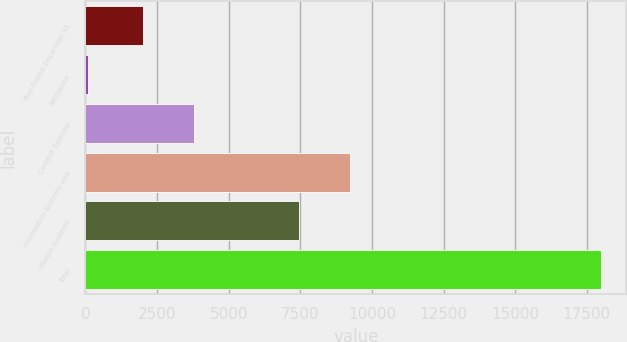Convert chart to OTSL. <chart><loc_0><loc_0><loc_500><loc_500><bar_chart><fcel>Year Ended December 31<fcel>Aerospace<fcel>Combat Systems<fcel>Information Systems and<fcel>Marine Systems<fcel>Total<nl><fcel>2015<fcel>104<fcel>3802.7<fcel>9225.7<fcel>7438<fcel>17981<nl></chart> 